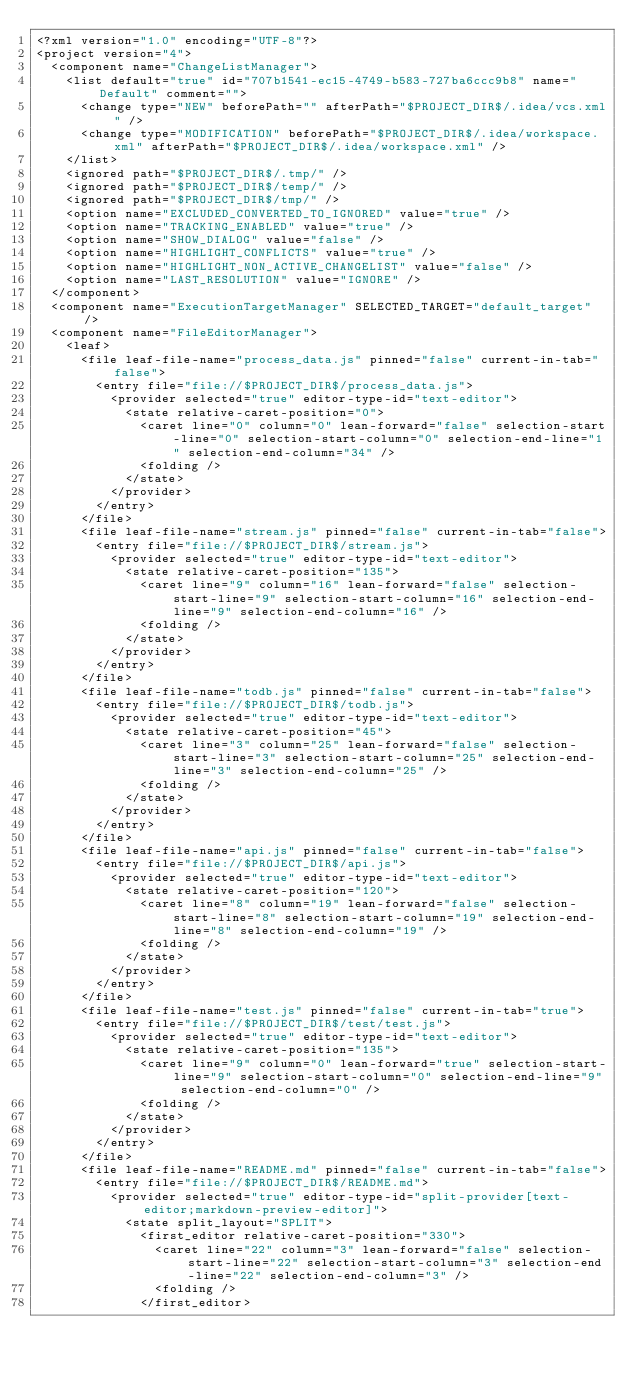Convert code to text. <code><loc_0><loc_0><loc_500><loc_500><_XML_><?xml version="1.0" encoding="UTF-8"?>
<project version="4">
  <component name="ChangeListManager">
    <list default="true" id="707b1541-ec15-4749-b583-727ba6ccc9b8" name="Default" comment="">
      <change type="NEW" beforePath="" afterPath="$PROJECT_DIR$/.idea/vcs.xml" />
      <change type="MODIFICATION" beforePath="$PROJECT_DIR$/.idea/workspace.xml" afterPath="$PROJECT_DIR$/.idea/workspace.xml" />
    </list>
    <ignored path="$PROJECT_DIR$/.tmp/" />
    <ignored path="$PROJECT_DIR$/temp/" />
    <ignored path="$PROJECT_DIR$/tmp/" />
    <option name="EXCLUDED_CONVERTED_TO_IGNORED" value="true" />
    <option name="TRACKING_ENABLED" value="true" />
    <option name="SHOW_DIALOG" value="false" />
    <option name="HIGHLIGHT_CONFLICTS" value="true" />
    <option name="HIGHLIGHT_NON_ACTIVE_CHANGELIST" value="false" />
    <option name="LAST_RESOLUTION" value="IGNORE" />
  </component>
  <component name="ExecutionTargetManager" SELECTED_TARGET="default_target" />
  <component name="FileEditorManager">
    <leaf>
      <file leaf-file-name="process_data.js" pinned="false" current-in-tab="false">
        <entry file="file://$PROJECT_DIR$/process_data.js">
          <provider selected="true" editor-type-id="text-editor">
            <state relative-caret-position="0">
              <caret line="0" column="0" lean-forward="false" selection-start-line="0" selection-start-column="0" selection-end-line="1" selection-end-column="34" />
              <folding />
            </state>
          </provider>
        </entry>
      </file>
      <file leaf-file-name="stream.js" pinned="false" current-in-tab="false">
        <entry file="file://$PROJECT_DIR$/stream.js">
          <provider selected="true" editor-type-id="text-editor">
            <state relative-caret-position="135">
              <caret line="9" column="16" lean-forward="false" selection-start-line="9" selection-start-column="16" selection-end-line="9" selection-end-column="16" />
              <folding />
            </state>
          </provider>
        </entry>
      </file>
      <file leaf-file-name="todb.js" pinned="false" current-in-tab="false">
        <entry file="file://$PROJECT_DIR$/todb.js">
          <provider selected="true" editor-type-id="text-editor">
            <state relative-caret-position="45">
              <caret line="3" column="25" lean-forward="false" selection-start-line="3" selection-start-column="25" selection-end-line="3" selection-end-column="25" />
              <folding />
            </state>
          </provider>
        </entry>
      </file>
      <file leaf-file-name="api.js" pinned="false" current-in-tab="false">
        <entry file="file://$PROJECT_DIR$/api.js">
          <provider selected="true" editor-type-id="text-editor">
            <state relative-caret-position="120">
              <caret line="8" column="19" lean-forward="false" selection-start-line="8" selection-start-column="19" selection-end-line="8" selection-end-column="19" />
              <folding />
            </state>
          </provider>
        </entry>
      </file>
      <file leaf-file-name="test.js" pinned="false" current-in-tab="true">
        <entry file="file://$PROJECT_DIR$/test/test.js">
          <provider selected="true" editor-type-id="text-editor">
            <state relative-caret-position="135">
              <caret line="9" column="0" lean-forward="true" selection-start-line="9" selection-start-column="0" selection-end-line="9" selection-end-column="0" />
              <folding />
            </state>
          </provider>
        </entry>
      </file>
      <file leaf-file-name="README.md" pinned="false" current-in-tab="false">
        <entry file="file://$PROJECT_DIR$/README.md">
          <provider selected="true" editor-type-id="split-provider[text-editor;markdown-preview-editor]">
            <state split_layout="SPLIT">
              <first_editor relative-caret-position="330">
                <caret line="22" column="3" lean-forward="false" selection-start-line="22" selection-start-column="3" selection-end-line="22" selection-end-column="3" />
                <folding />
              </first_editor></code> 